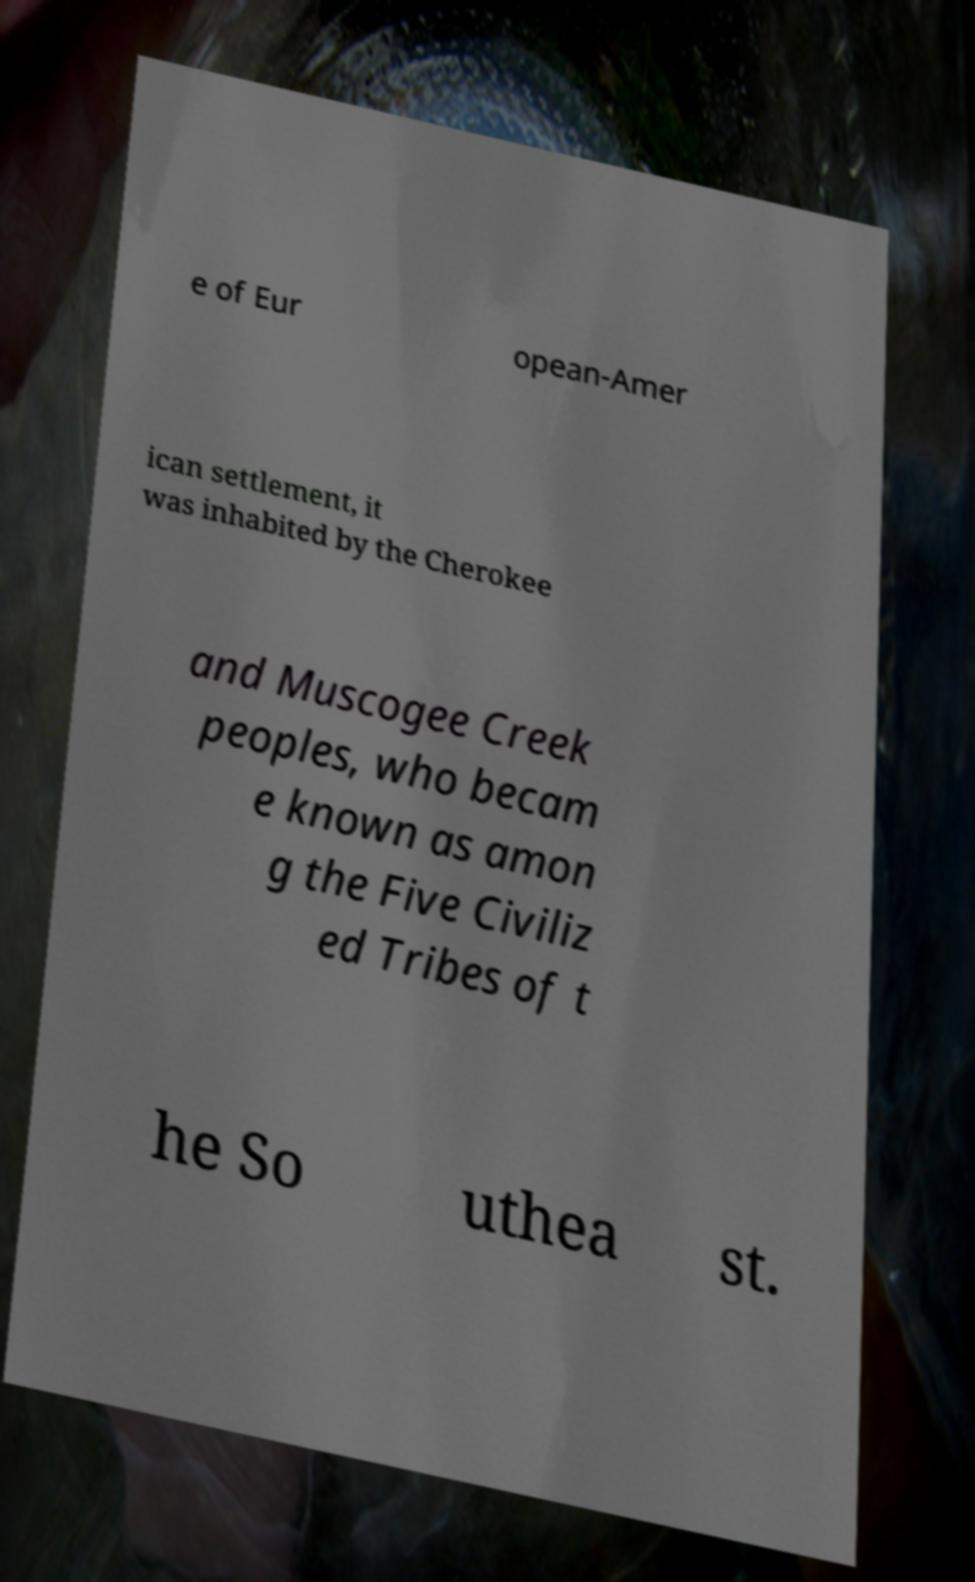Can you accurately transcribe the text from the provided image for me? e of Eur opean-Amer ican settlement, it was inhabited by the Cherokee and Muscogee Creek peoples, who becam e known as amon g the Five Civiliz ed Tribes of t he So uthea st. 